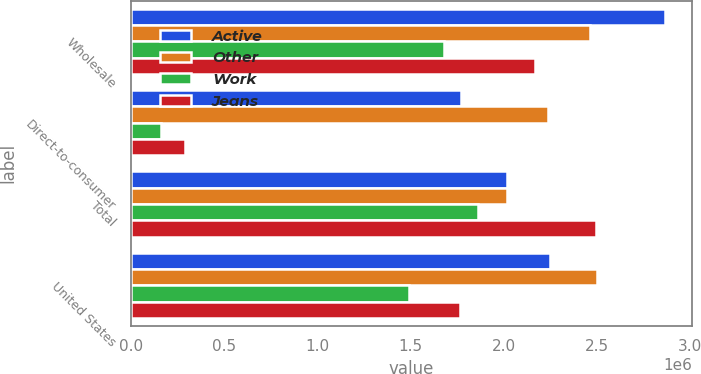<chart> <loc_0><loc_0><loc_500><loc_500><stacked_bar_chart><ecel><fcel>Wholesale<fcel>Direct-to-consumer<fcel>Total<fcel>United States<nl><fcel>Active<fcel>2.86563e+06<fcel>1.77058e+06<fcel>2.01555e+06<fcel>2.24671e+06<nl><fcel>Other<fcel>2.46069e+06<fcel>2.23405e+06<fcel>2.01555e+06<fcel>2.49939e+06<nl><fcel>Work<fcel>1.67847e+06<fcel>160970<fcel>1.86202e+06<fcel>1.49255e+06<nl><fcel>Jeans<fcel>2.16909e+06<fcel>289196<fcel>2.49177e+06<fcel>1.76358e+06<nl></chart> 